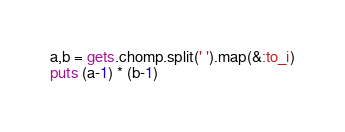Convert code to text. <code><loc_0><loc_0><loc_500><loc_500><_Ruby_>a,b = gets.chomp.split(' ').map(&:to_i)
puts (a-1) * (b-1)</code> 